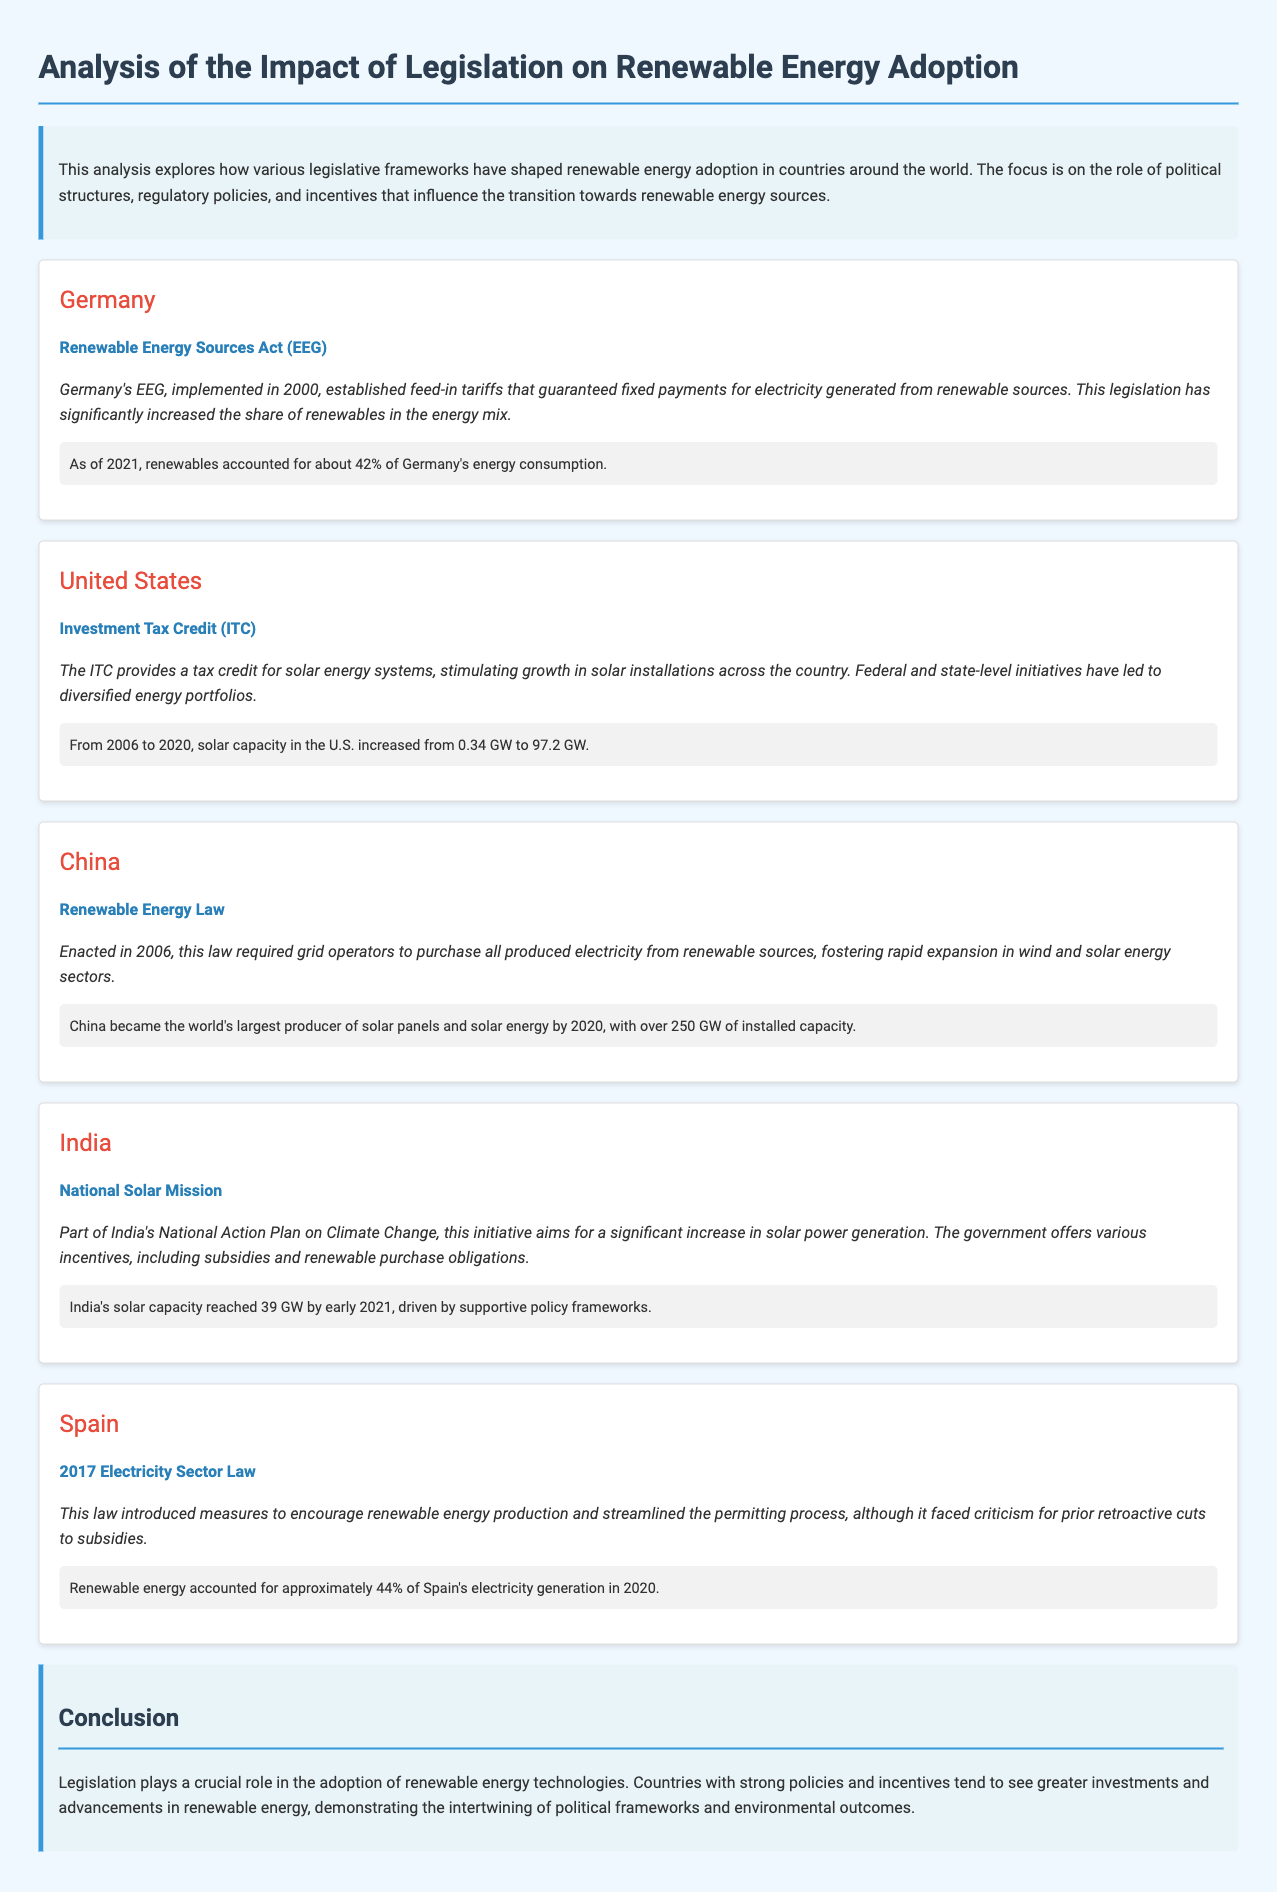what is the title of the document? The title of the document is found in the header of the HTML, indicating the main subject of the analysis.
Answer: Analysis of the Impact of Legislation on Renewable Energy Adoption which country has the Renewable Energy Sources Act? The Renewable Energy Sources Act (EEG) is legislation specific to one of the countries discussed in the document.
Answer: Germany what percentage of energy consumption in Germany is from renewables as of 2021? The document states the percentage of Germany's energy consumption derived from renewables at a specific point in time.
Answer: about 42% when was the Renewable Energy Law enacted in China? This question asks for the specific year that a key piece of legislation was introduced in China, as outlined in the text.
Answer: 2006 how much solar capacity did the U.S. have in 2020? The document provides a figure that represents the solar energy capacity in the United States at a given year.
Answer: 97.2 GW what major factor influenced renewable energy adoption in India? The document highlights specific initiatives that have facilitated the growth of renewable energy in India, pointing to a broader governmental approach.
Answer: National Solar Mission what percentage of electricity generation in Spain came from renewables in 2020? The document mentions a statistic regarding the share of electricity from renewable sources in Spain for a particular year, which helps understand the energy mix.
Answer: approximately 44% what role does legislation play according to the conclusion? The conclusion emphasizes the overarching impact that laws and regulations have regarding renewable energy adoption, reflecting the document's central thesis.
Answer: crucial role 